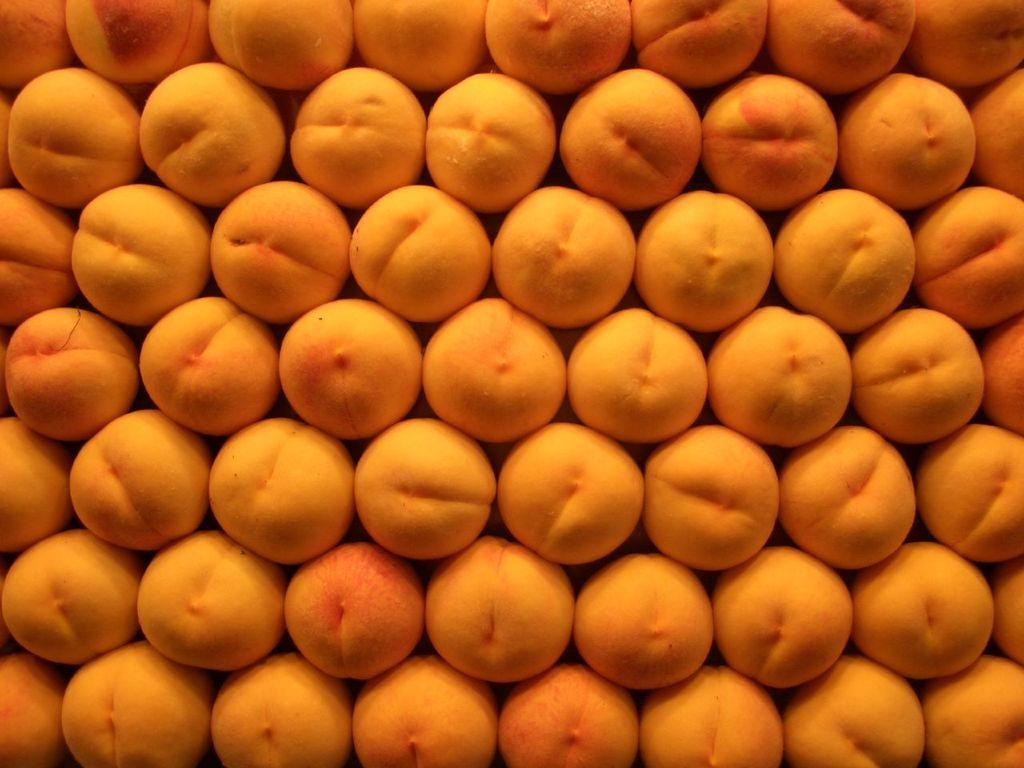What type of fruits are in the image? There are peach fruits in the image. How many peach fruits are visible in the image? The peach fruits are in a bulk quantity, so there are many visible in the image. Can you determine the time of day when the image was taken? The image may have been taken during the day, but the exact time cannot be determined. What level of experience does the beginner have with the boot in the image? There is no beginner or boot present in the image; it features peach fruits. What type of connection is established between the peach fruits in the image? There is no connection established between the peach fruits in the image; they are simply a collection of fruits. 